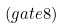Convert formula to latex. <formula><loc_0><loc_0><loc_500><loc_500>( g a t e 8 )</formula> 